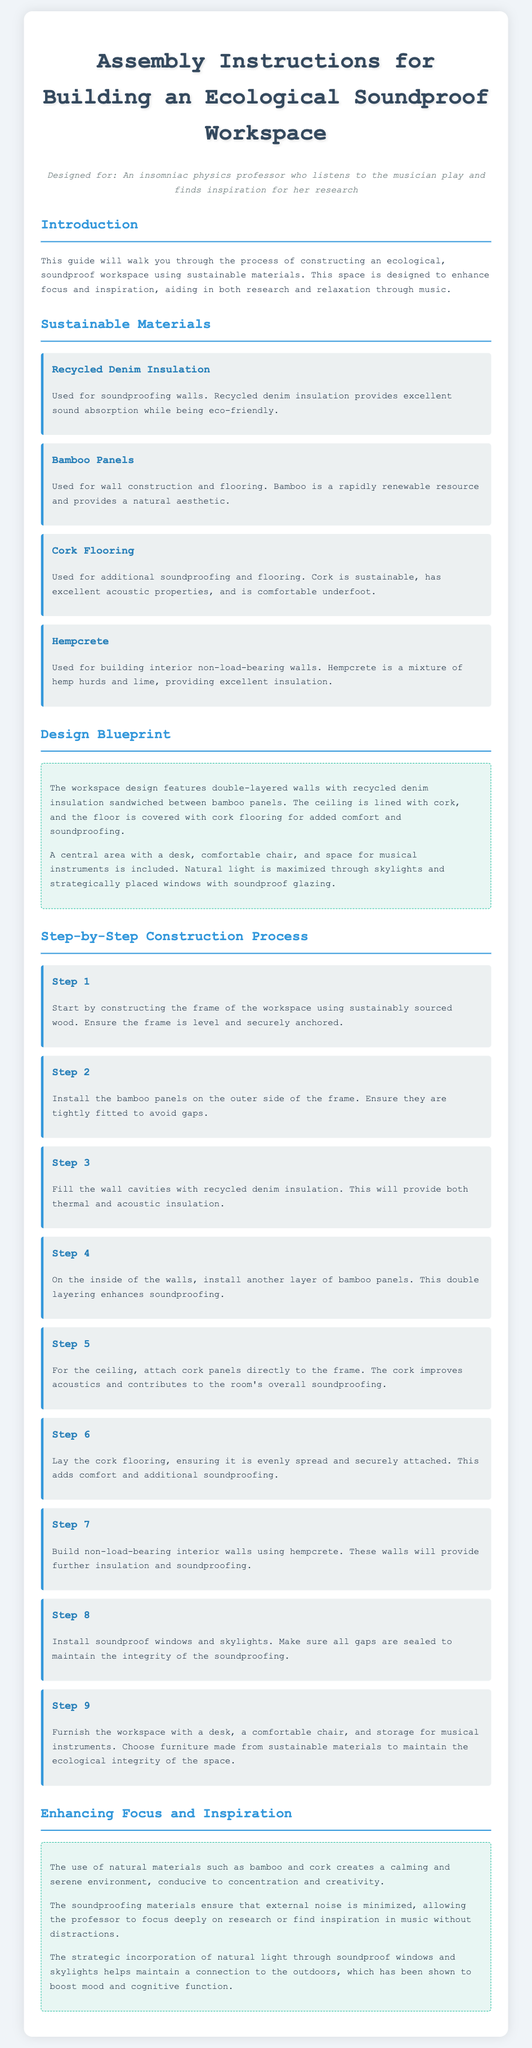what material is used for soundproofing walls? The document states that recycled denim insulation is used for soundproofing walls, providing excellent sound absorption.
Answer: recycled denim insulation how many steps are in the construction process? The construction process is divided into nine steps, detailing the assembly of the ecological workspace.
Answer: 9 what is the primary purpose of the workspace design? The workspace is designed to enhance focus and inspiration, aiding in research and relaxation through music.
Answer: enhance focus and inspiration which layer improves acoustics in the ceiling? The document mentions that cork panels are attached to the ceiling to improve acoustics and contribute to soundproofing.
Answer: cork panels what sustainable material is used for flooring? The instructions specify that cork is used for flooring, offering both comfort and soundproofing features.
Answer: cork why is natural light important in this workspace? The document highlights that natural light maximizes mood and cognitive function, which helps boost overall productivity.
Answer: boosts mood and cognitive function what type of walls are built using hempcrete? According to the instructions, hempcrete is used to build non-load-bearing interior walls to provide insulation and soundproofing.
Answer: non-load-bearing interior walls what design feature does the workspace maximally incorporate? The design maximally incorporates natural light through the implementation of skylights and strategically placed windows.
Answer: natural light 